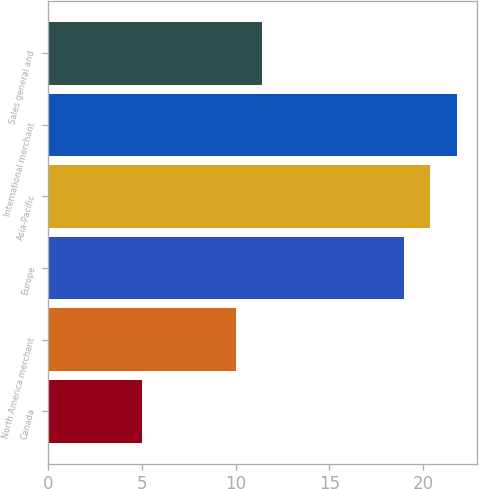Convert chart to OTSL. <chart><loc_0><loc_0><loc_500><loc_500><bar_chart><fcel>Canada<fcel>North America merchant<fcel>Europe<fcel>Asia-Pacific<fcel>International merchant<fcel>Sales general and<nl><fcel>5<fcel>10<fcel>19<fcel>20.4<fcel>21.8<fcel>11.4<nl></chart> 